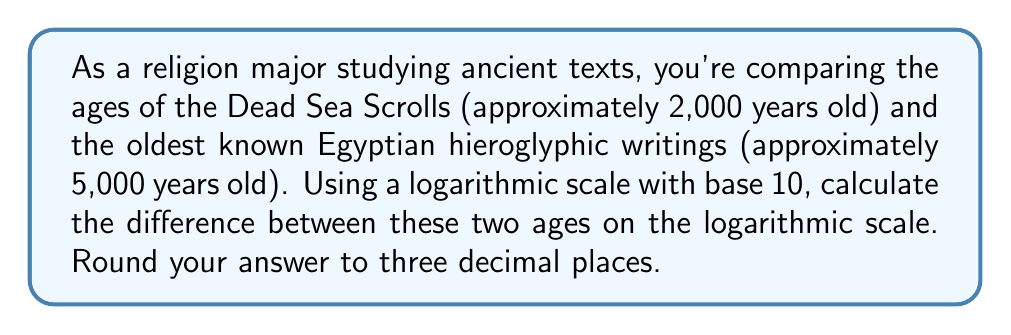Could you help me with this problem? To solve this problem, we need to follow these steps:

1. Convert the ages to logarithmic values using base 10.
2. Subtract the logarithmic values.

Let's start:

1. Converting ages to logarithmic values:
   For Dead Sea Scrolls: $\log_{10}(2000) = 3.301$
   For Egyptian hieroglyphics: $\log_{10}(5000) = 3.699$

2. Subtracting the logarithmic values:
   $$\log_{10}(5000) - \log_{10}(2000) = 3.699 - 3.301 = 0.398$$

The difference on the logarithmic scale is 0.398.

This logarithmic difference represents the ratio between the two ages:

$$10^{0.398} \approx 2.5$$

This means that the Egyptian hieroglyphics are about 2.5 times older than the Dead Sea Scrolls, which aligns with their actual ages (5000/2000 = 2.5).

Using a logarithmic scale allows us to compare vastly different time scales more easily, which is particularly useful when studying ancient religious artifacts and texts that can vary greatly in age.
Answer: 0.398 